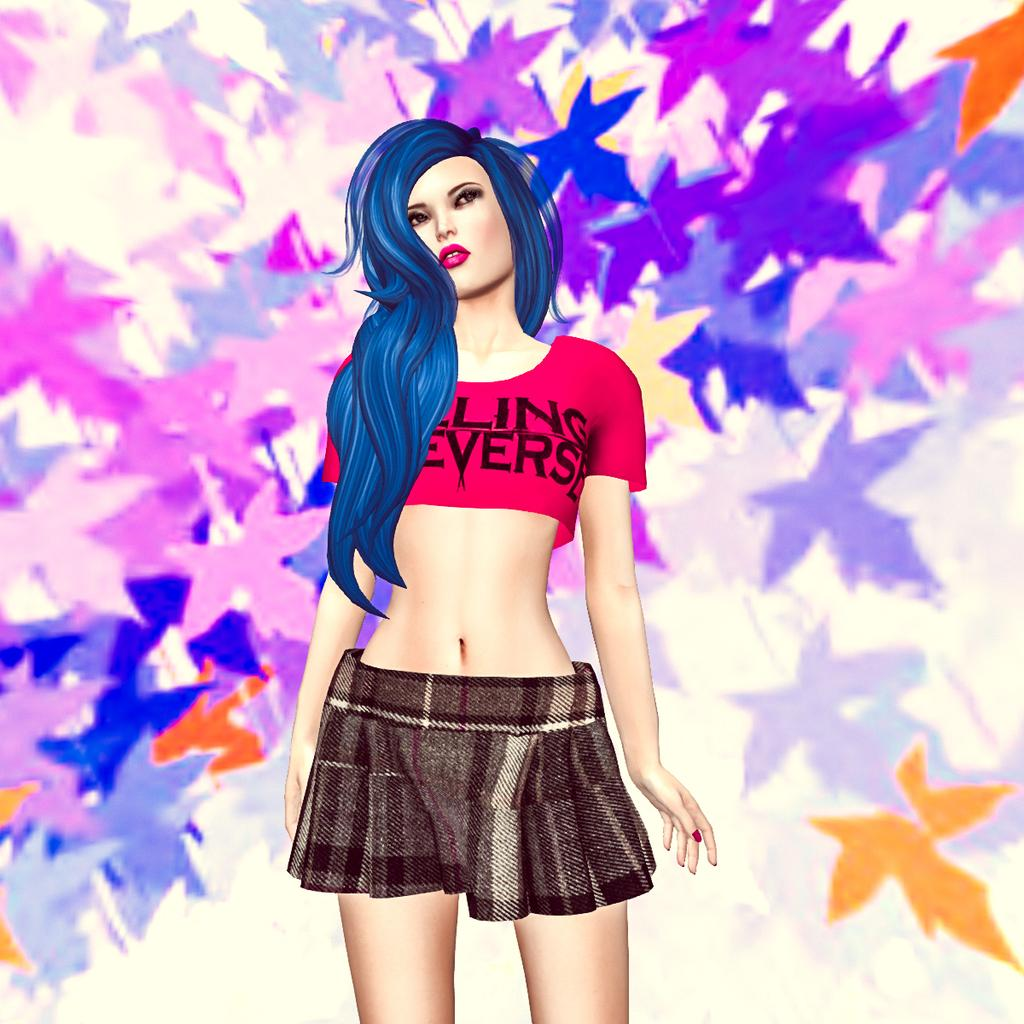<image>
Give a short and clear explanation of the subsequent image. Blue hair covers a shirt that appears to say ling everse. 